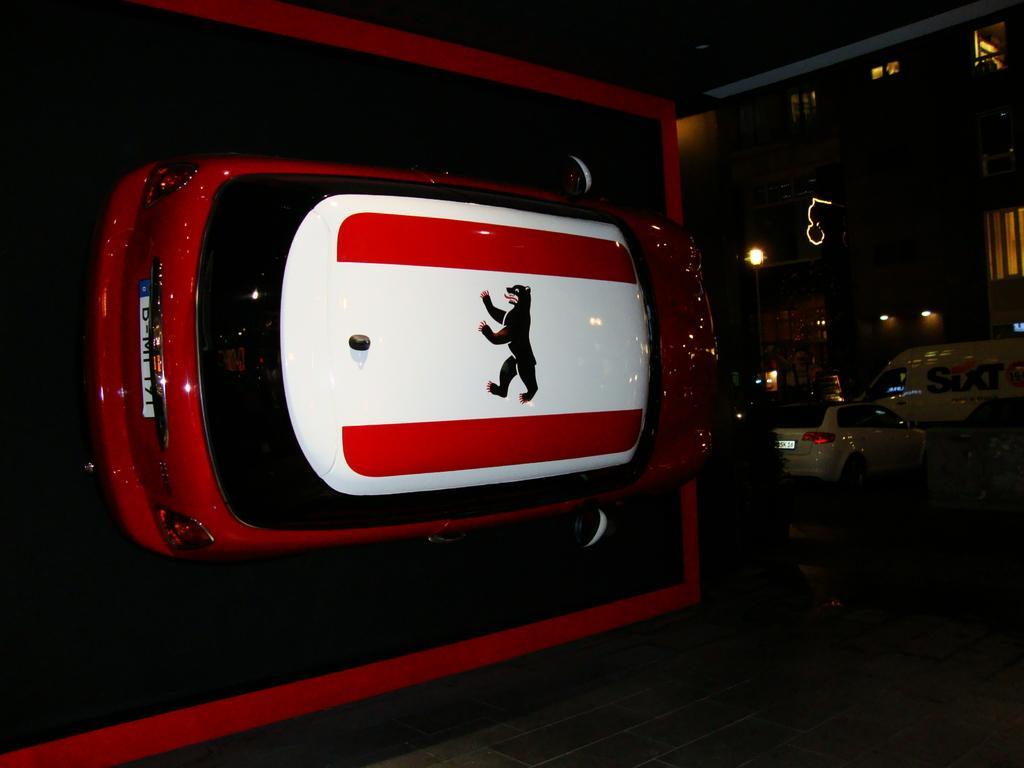Describe this image in one or two sentences. In this picture we can observe a car on the floor. This car is in red and white colors. We can observe some vehicles on the road. The background is dark. 